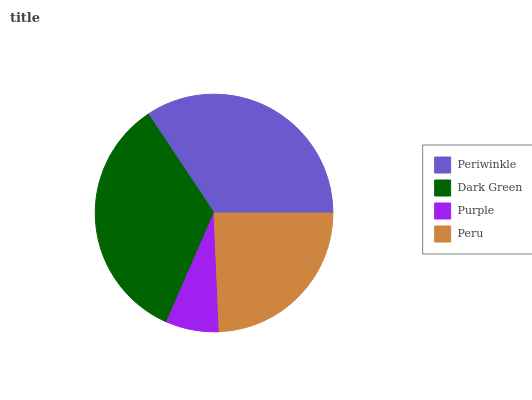Is Purple the minimum?
Answer yes or no. Yes. Is Periwinkle the maximum?
Answer yes or no. Yes. Is Dark Green the minimum?
Answer yes or no. No. Is Dark Green the maximum?
Answer yes or no. No. Is Periwinkle greater than Dark Green?
Answer yes or no. Yes. Is Dark Green less than Periwinkle?
Answer yes or no. Yes. Is Dark Green greater than Periwinkle?
Answer yes or no. No. Is Periwinkle less than Dark Green?
Answer yes or no. No. Is Dark Green the high median?
Answer yes or no. Yes. Is Peru the low median?
Answer yes or no. Yes. Is Purple the high median?
Answer yes or no. No. Is Periwinkle the low median?
Answer yes or no. No. 